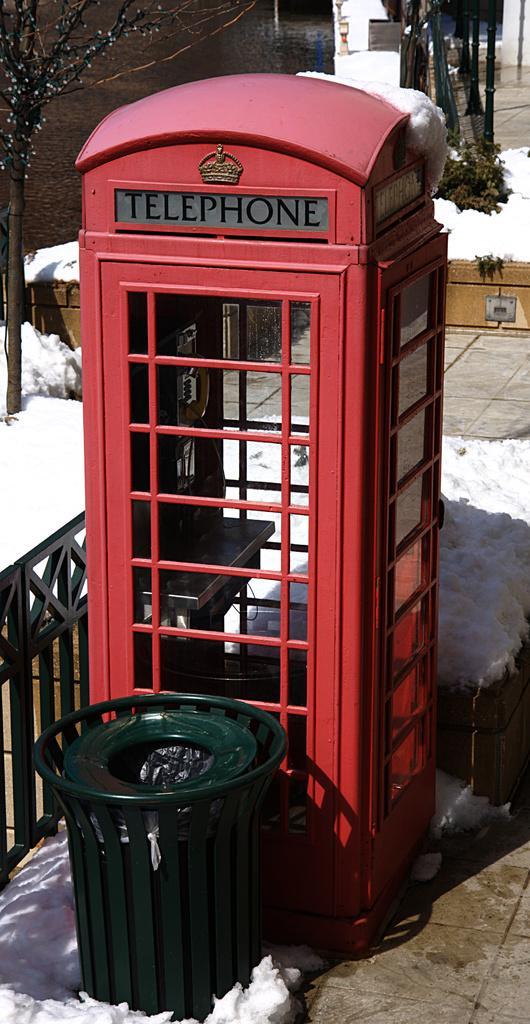In one or two sentences, can you explain what this image depicts? In the image we can see a telephone booth, garbage bin, fence, snow, footpath, plant and tree. 